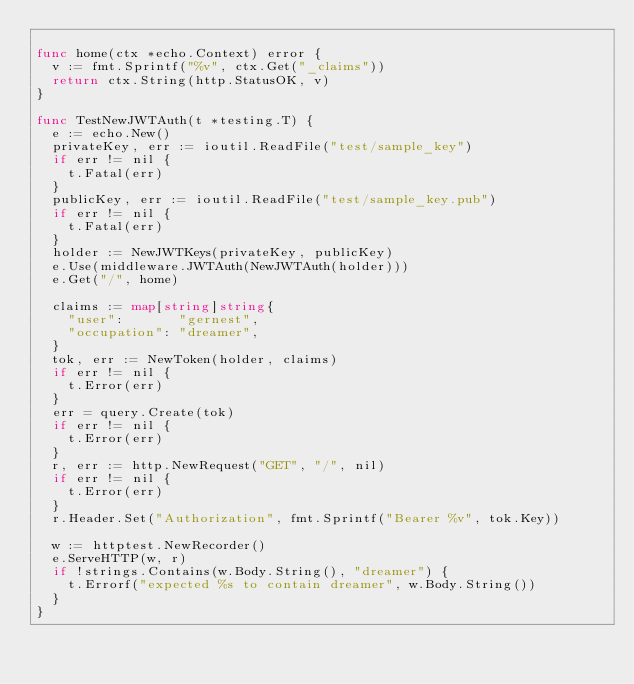<code> <loc_0><loc_0><loc_500><loc_500><_Go_>
func home(ctx *echo.Context) error {
	v := fmt.Sprintf("%v", ctx.Get("_claims"))
	return ctx.String(http.StatusOK, v)
}

func TestNewJWTAuth(t *testing.T) {
	e := echo.New()
	privateKey, err := ioutil.ReadFile("test/sample_key")
	if err != nil {
		t.Fatal(err)
	}
	publicKey, err := ioutil.ReadFile("test/sample_key.pub")
	if err != nil {
		t.Fatal(err)
	}
	holder := NewJWTKeys(privateKey, publicKey)
	e.Use(middleware.JWTAuth(NewJWTAuth(holder)))
	e.Get("/", home)

	claims := map[string]string{
		"user":       "gernest",
		"occupation": "dreamer",
	}
	tok, err := NewToken(holder, claims)
	if err != nil {
		t.Error(err)
	}
	err = query.Create(tok)
	if err != nil {
		t.Error(err)
	}
	r, err := http.NewRequest("GET", "/", nil)
	if err != nil {
		t.Error(err)
	}
	r.Header.Set("Authorization", fmt.Sprintf("Bearer %v", tok.Key))

	w := httptest.NewRecorder()
	e.ServeHTTP(w, r)
	if !strings.Contains(w.Body.String(), "dreamer") {
		t.Errorf("expected %s to contain dreamer", w.Body.String())
	}
}
</code> 